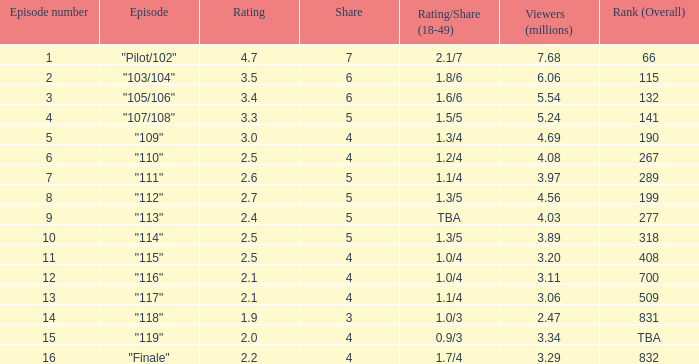What is the evaluation that had a fraction below 4, and 0.0. 